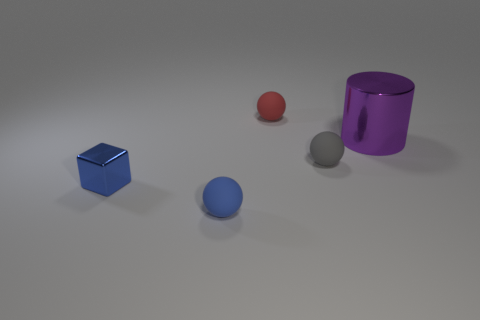Does the cylinder have the same size as the blue object in front of the block?
Ensure brevity in your answer.  No. What number of small shiny things are the same color as the large metal thing?
Give a very brief answer. 0. What number of things are large blue matte cylinders or small balls behind the blue shiny thing?
Keep it short and to the point. 2. Do the object behind the large metal cylinder and the metal thing behind the tiny block have the same size?
Ensure brevity in your answer.  No. Are there any big yellow blocks that have the same material as the tiny gray thing?
Provide a short and direct response. No. What shape is the small red rubber thing?
Provide a short and direct response. Sphere. There is a tiny matte thing on the right side of the rubber object that is behind the large object; what shape is it?
Make the answer very short. Sphere. How many other things are there of the same shape as the big object?
Your answer should be compact. 0. There is a matte ball in front of the blue object behind the blue matte object; how big is it?
Ensure brevity in your answer.  Small. Are any metallic things visible?
Offer a terse response. Yes. 